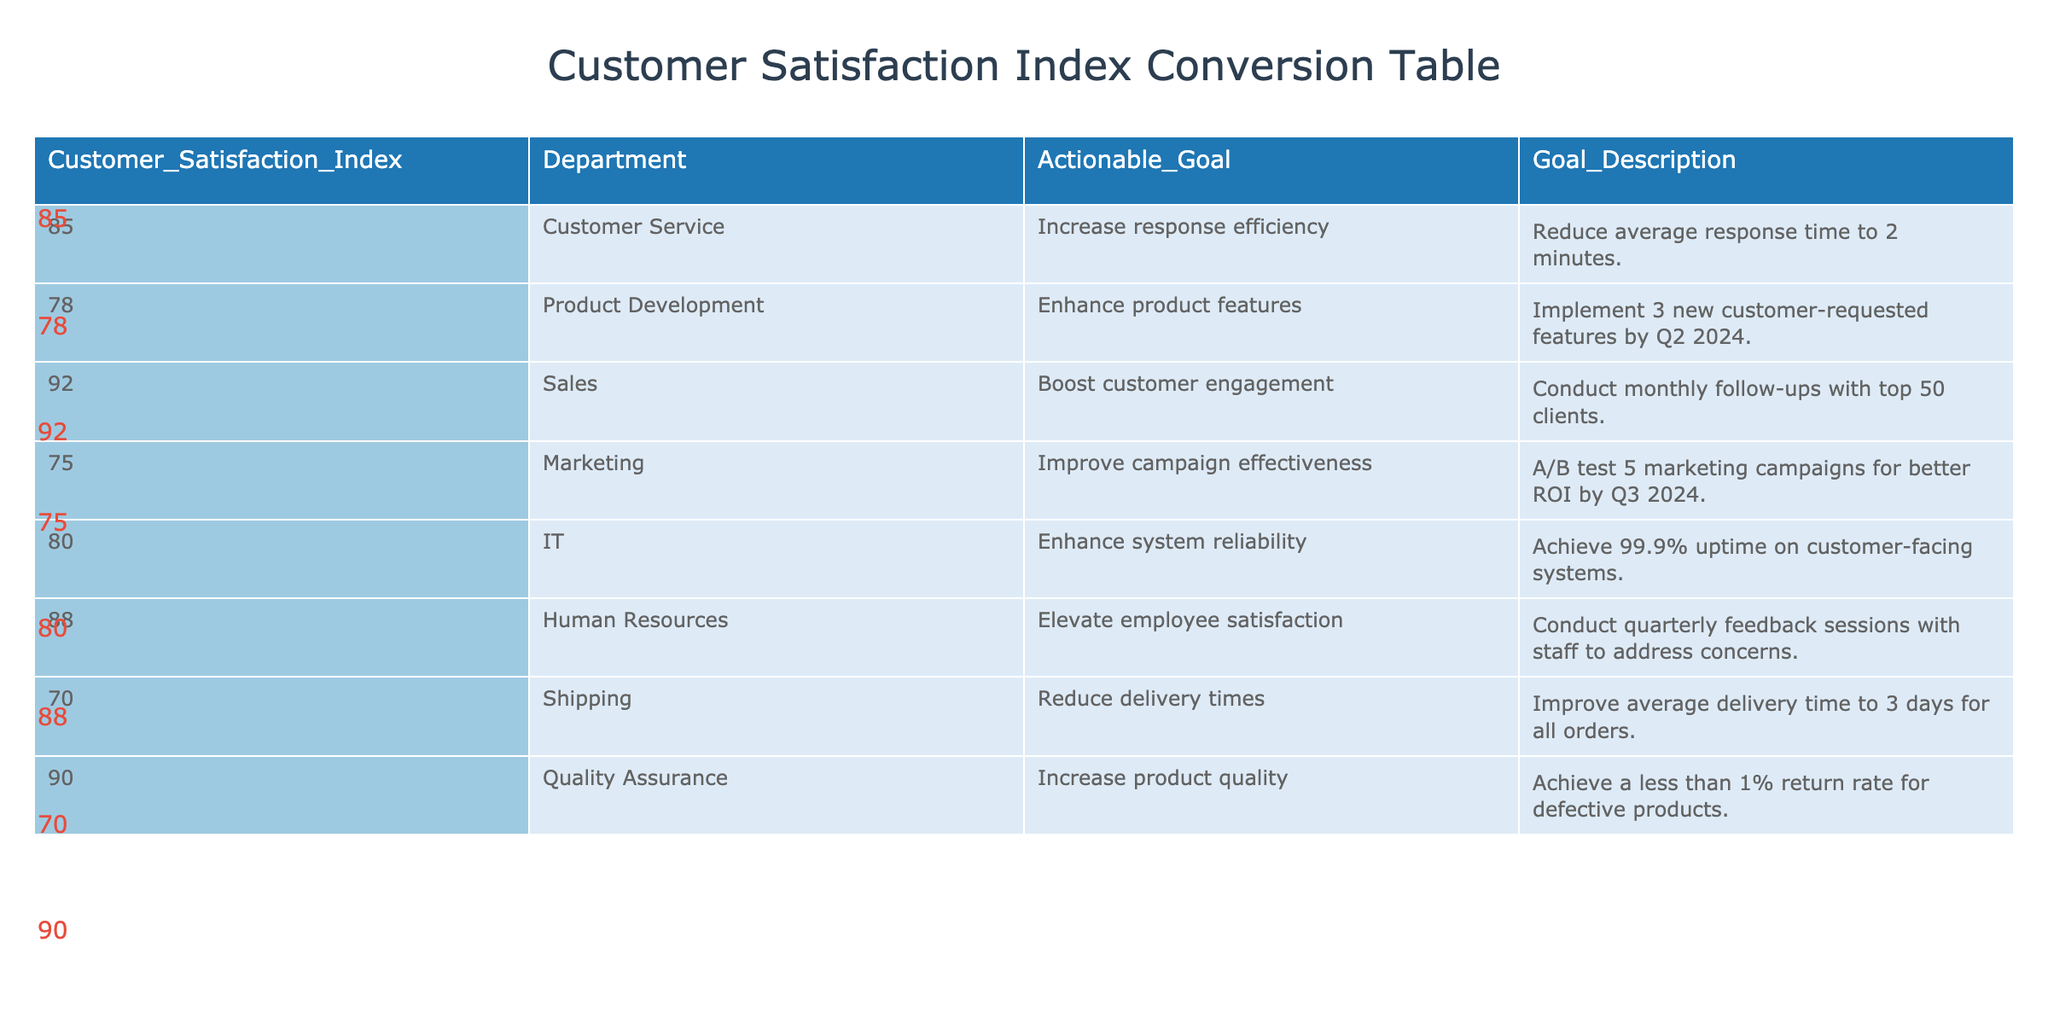What is the Customer Satisfaction Index for the IT department? Looking at the table, under the "Customer Satisfaction Index" column, the value corresponding to the IT department is 80.
Answer: 80 Which department has the highest Customer Satisfaction Index? The highest value in the "Customer Satisfaction Index" column is 92, which corresponds to the Sales department.
Answer: Sales What is the actionable goal for the Marketing department? The table states that the actionable goal for the Marketing department is to A/B test 5 marketing campaigns for better ROI by Q3 2024.
Answer: Improve campaign effectiveness Is it true that the Shipping department's goal is to improve average delivery time to less than 2 days? Referring to the table, the goal for the Shipping department is to improve the average delivery time to 3 days for all orders, which is not less than 2 days. Therefore, this statement is false.
Answer: No What is the difference between the Customer Satisfaction Index of the Quality Assurance and Shipping departments? The Customer Satisfaction Index for Quality Assurance is 90 and for Shipping is 70. The difference is calculated as 90 - 70 = 20.
Answer: 20 If we average the Customer Satisfaction Index for all departments, what do we get? To find the average, first sum the Customer Satisfaction Indices: (85 + 78 + 92 + 75 + 80 + 88 + 70 + 90) = 688. There are 8 departments, so the average is 688 / 8 = 86.
Answer: 86 How many departments have a Customer Satisfaction Index of 80 or above? By checking the indices, the departments with 80 or above are Customer Service (85), Product Development (78), Sales (92), IT (80), Human Resources (88), and Quality Assurance (90). This totals to 6 departments.
Answer: 6 What is the actionable goal of the Human Resources department? The table indicates that the Human Resources department's actionable goal is to conduct quarterly feedback sessions with staff to address concerns.
Answer: Elevate employee satisfaction Which department needs to implement 3 new customer-requested features by Q2 2024? According to the table, the department responsible for implementing 3 new customer-requested features by Q2 2024 is Product Development.
Answer: Product Development 